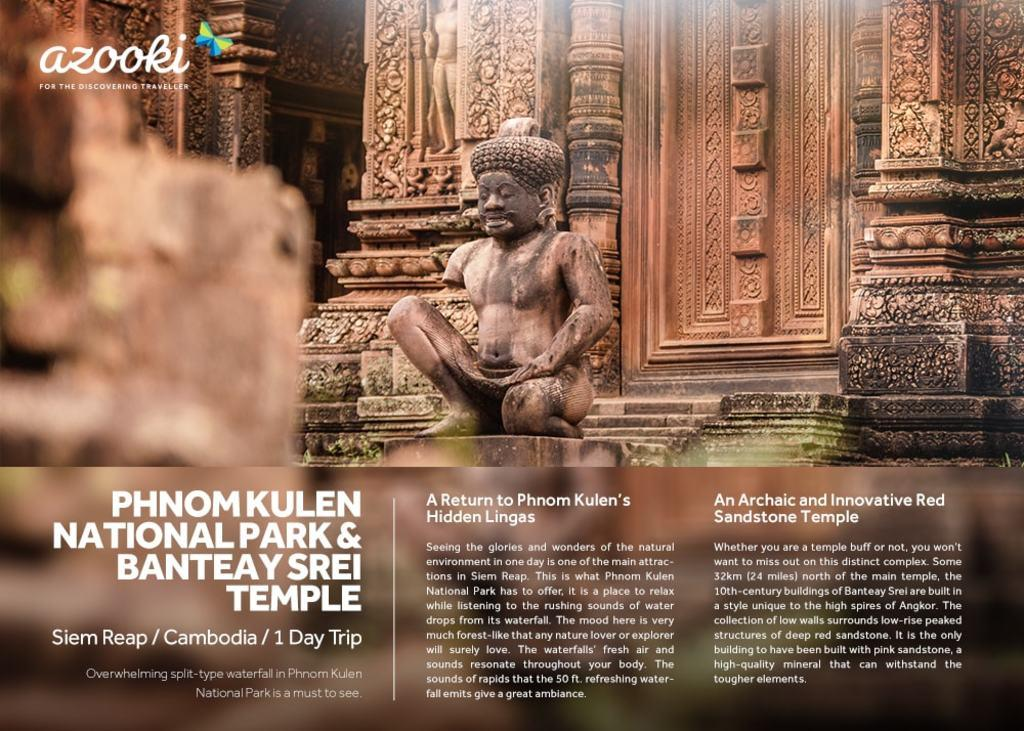What is featured on the wall in the image? There is a poster in the image. What can be seen on the walls besides the poster? The walls in the image have carvings. What type of artwork is present in the image? There is a sculpture in the image. What is written or depicted on the poster? There is text or writing on the poster. What color is the pail that is being used to draw a line on the wrist in the image? There is no pail, line, or wrist present in the image. 